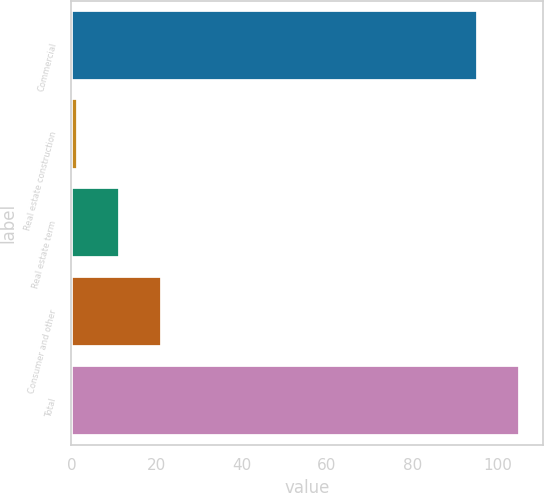Convert chart to OTSL. <chart><loc_0><loc_0><loc_500><loc_500><bar_chart><fcel>Commercial<fcel>Real estate construction<fcel>Real estate term<fcel>Consumer and other<fcel>Total<nl><fcel>95.5<fcel>1.5<fcel>11.35<fcel>21.2<fcel>105.35<nl></chart> 